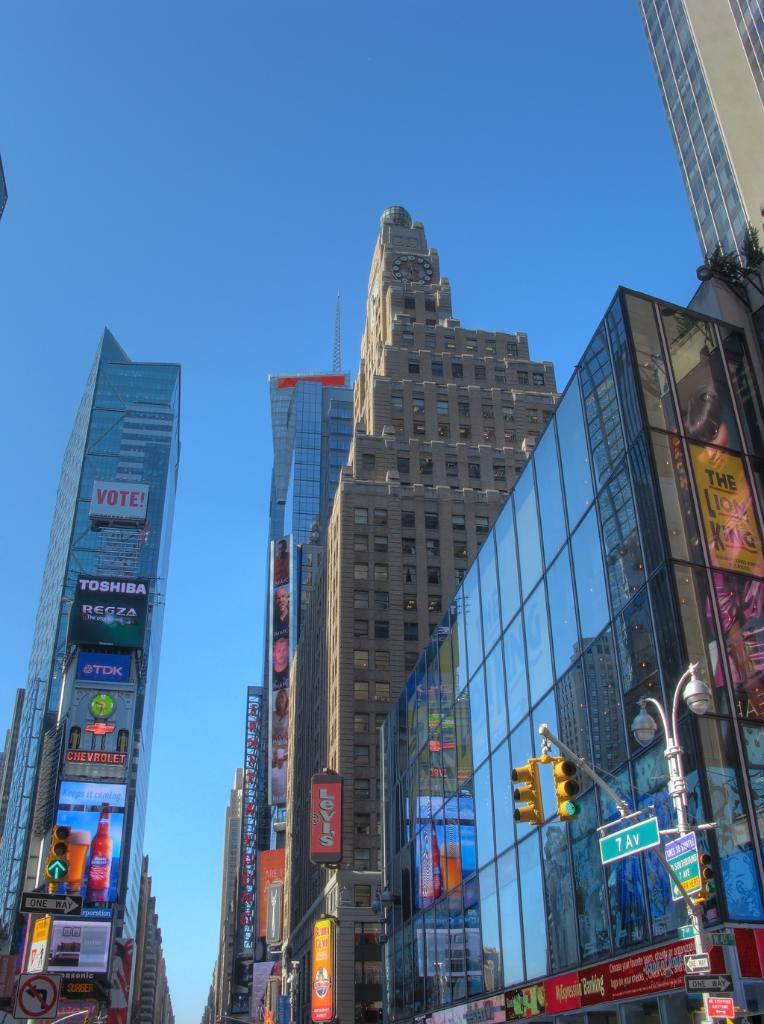What type of structures can be seen in the image? There are buildings with windows in the image. What other objects are present in the image related to traffic or transportation? Signal light poles are present in the image. Are there any signs or advertisements on the signal light poles? Yes, sign boards are present on the signal light poles. What else can be seen in the image related to advertising or information? There are hoardings in the image. What is the color of the sky in the image? The sky is blue in color. How many beggars can be seen in the image? There are no beggars present in the image. What year does the image depict? The image does not depict a specific year; it is a static representation. 